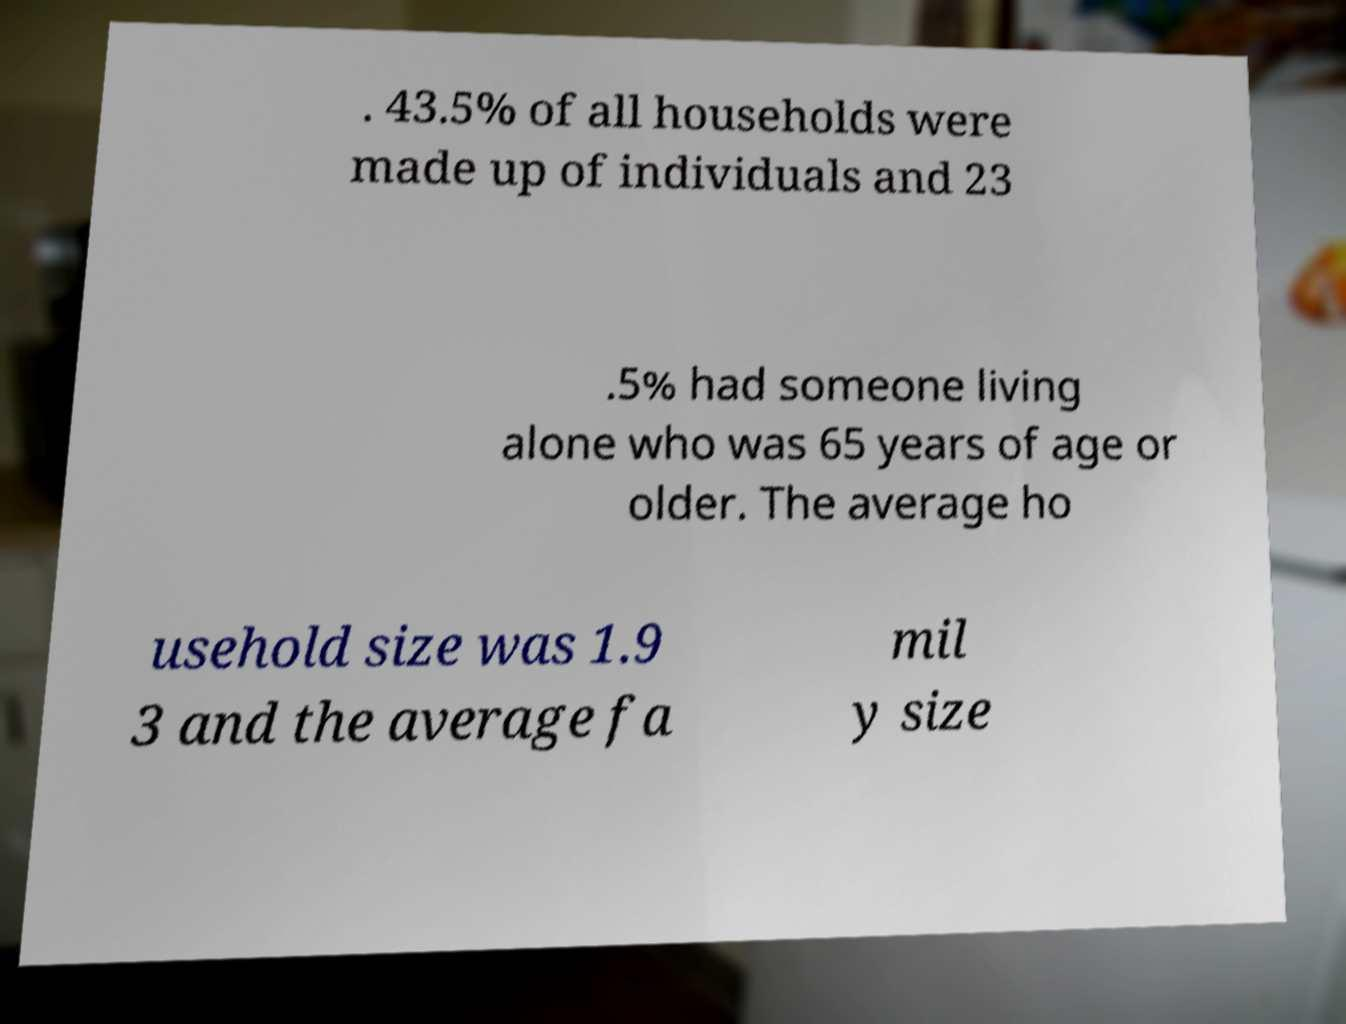Could you extract and type out the text from this image? . 43.5% of all households were made up of individuals and 23 .5% had someone living alone who was 65 years of age or older. The average ho usehold size was 1.9 3 and the average fa mil y size 